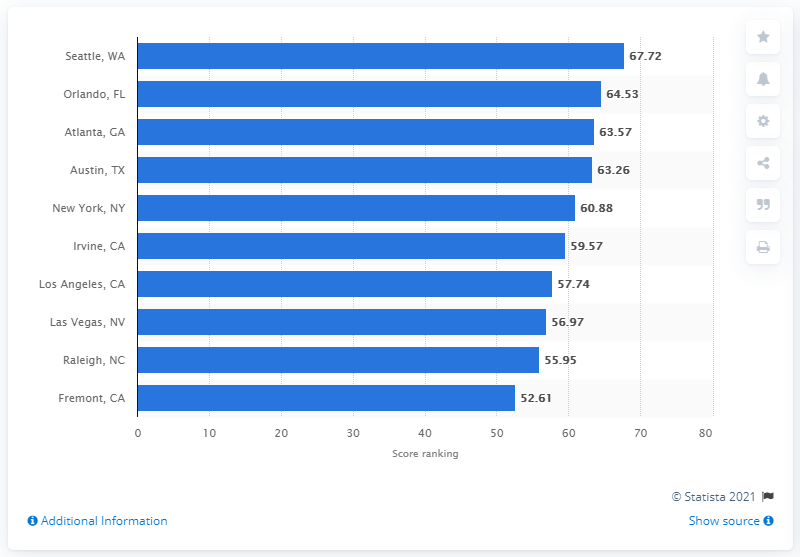List a handful of essential elements in this visual. In 2018, Seattle's score was 67.72 out of 100. Orlando's score was 64.53 out of 100. 